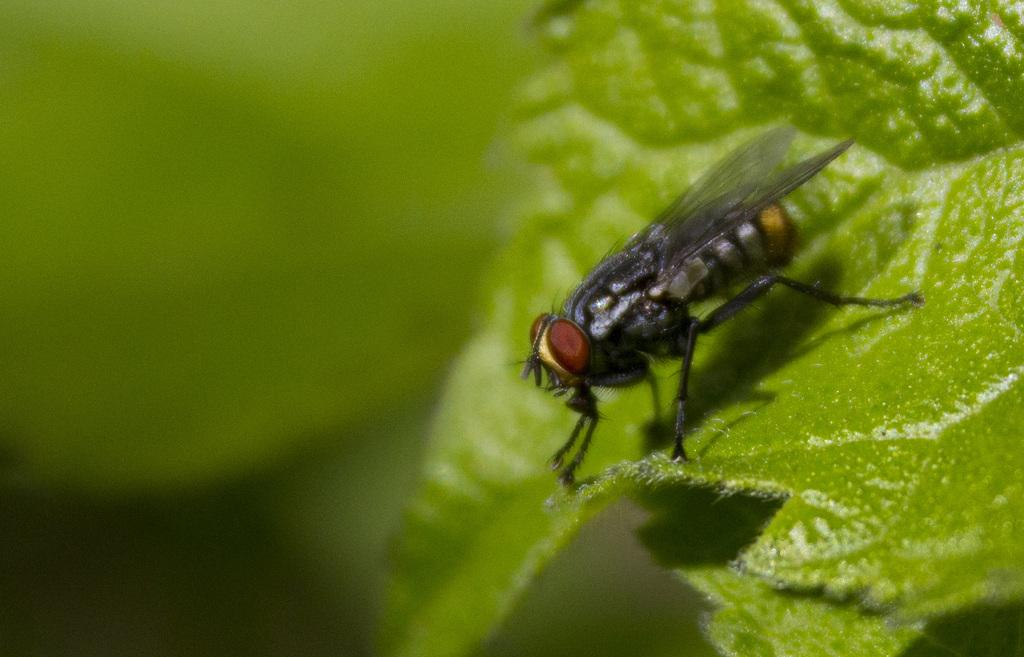What is present in the image? There is a fly in the image. Where is the fly located? The fly is sitting on a green leaf. How many rabbits can be seen playing with a ring in the alley in the image? There are no rabbits, rings, or alleys present in the image. 